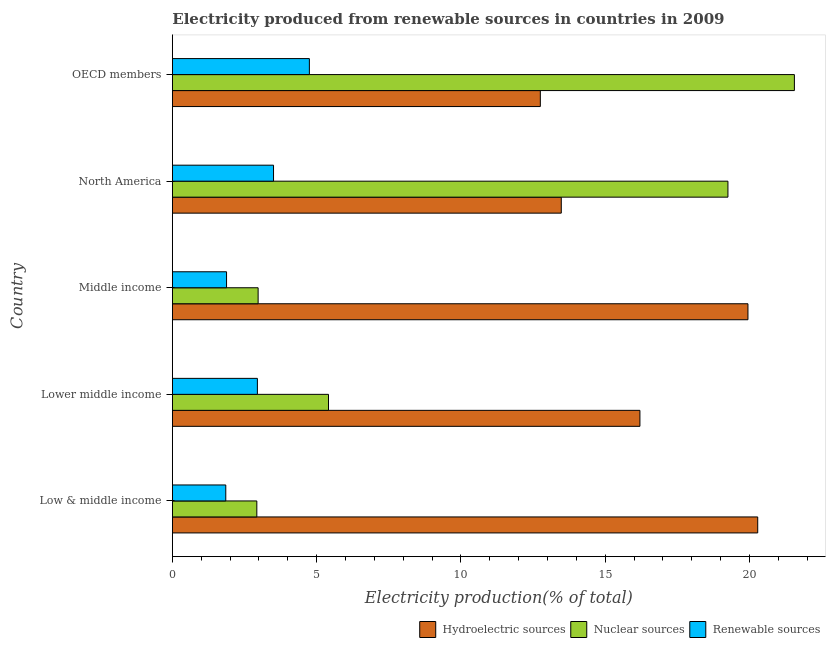How many different coloured bars are there?
Offer a very short reply. 3. Are the number of bars on each tick of the Y-axis equal?
Your response must be concise. Yes. What is the label of the 3rd group of bars from the top?
Ensure brevity in your answer.  Middle income. What is the percentage of electricity produced by hydroelectric sources in Low & middle income?
Give a very brief answer. 20.29. Across all countries, what is the maximum percentage of electricity produced by nuclear sources?
Your answer should be very brief. 21.56. Across all countries, what is the minimum percentage of electricity produced by renewable sources?
Give a very brief answer. 1.85. What is the total percentage of electricity produced by nuclear sources in the graph?
Offer a terse response. 52.12. What is the difference between the percentage of electricity produced by hydroelectric sources in Lower middle income and that in OECD members?
Give a very brief answer. 3.45. What is the difference between the percentage of electricity produced by hydroelectric sources in Low & middle income and the percentage of electricity produced by renewable sources in OECD members?
Offer a terse response. 15.54. What is the average percentage of electricity produced by hydroelectric sources per country?
Give a very brief answer. 16.54. What is the difference between the percentage of electricity produced by nuclear sources and percentage of electricity produced by renewable sources in Lower middle income?
Your answer should be compact. 2.46. What is the ratio of the percentage of electricity produced by hydroelectric sources in Middle income to that in North America?
Offer a very short reply. 1.48. What is the difference between the highest and the second highest percentage of electricity produced by hydroelectric sources?
Offer a very short reply. 0.34. What is the difference between the highest and the lowest percentage of electricity produced by hydroelectric sources?
Offer a very short reply. 7.53. Is the sum of the percentage of electricity produced by nuclear sources in Lower middle income and OECD members greater than the maximum percentage of electricity produced by hydroelectric sources across all countries?
Give a very brief answer. Yes. What does the 3rd bar from the top in OECD members represents?
Offer a terse response. Hydroelectric sources. What does the 3rd bar from the bottom in Lower middle income represents?
Keep it short and to the point. Renewable sources. How many countries are there in the graph?
Ensure brevity in your answer.  5. What is the difference between two consecutive major ticks on the X-axis?
Give a very brief answer. 5. Does the graph contain grids?
Your response must be concise. No. How many legend labels are there?
Ensure brevity in your answer.  3. How are the legend labels stacked?
Your answer should be compact. Horizontal. What is the title of the graph?
Ensure brevity in your answer.  Electricity produced from renewable sources in countries in 2009. Does "Agriculture" appear as one of the legend labels in the graph?
Provide a succinct answer. No. What is the label or title of the X-axis?
Keep it short and to the point. Electricity production(% of total). What is the Electricity production(% of total) in Hydroelectric sources in Low & middle income?
Offer a terse response. 20.29. What is the Electricity production(% of total) of Nuclear sources in Low & middle income?
Your answer should be very brief. 2.93. What is the Electricity production(% of total) in Renewable sources in Low & middle income?
Provide a succinct answer. 1.85. What is the Electricity production(% of total) of Hydroelectric sources in Lower middle income?
Ensure brevity in your answer.  16.2. What is the Electricity production(% of total) of Nuclear sources in Lower middle income?
Provide a succinct answer. 5.41. What is the Electricity production(% of total) in Renewable sources in Lower middle income?
Your response must be concise. 2.95. What is the Electricity production(% of total) in Hydroelectric sources in Middle income?
Offer a very short reply. 19.95. What is the Electricity production(% of total) in Nuclear sources in Middle income?
Your response must be concise. 2.97. What is the Electricity production(% of total) of Renewable sources in Middle income?
Your answer should be compact. 1.88. What is the Electricity production(% of total) of Hydroelectric sources in North America?
Your response must be concise. 13.48. What is the Electricity production(% of total) of Nuclear sources in North America?
Your answer should be very brief. 19.26. What is the Electricity production(% of total) of Renewable sources in North America?
Make the answer very short. 3.51. What is the Electricity production(% of total) of Hydroelectric sources in OECD members?
Your response must be concise. 12.75. What is the Electricity production(% of total) in Nuclear sources in OECD members?
Your response must be concise. 21.56. What is the Electricity production(% of total) in Renewable sources in OECD members?
Keep it short and to the point. 4.75. Across all countries, what is the maximum Electricity production(% of total) of Hydroelectric sources?
Provide a succinct answer. 20.29. Across all countries, what is the maximum Electricity production(% of total) in Nuclear sources?
Make the answer very short. 21.56. Across all countries, what is the maximum Electricity production(% of total) in Renewable sources?
Your answer should be compact. 4.75. Across all countries, what is the minimum Electricity production(% of total) in Hydroelectric sources?
Keep it short and to the point. 12.75. Across all countries, what is the minimum Electricity production(% of total) in Nuclear sources?
Make the answer very short. 2.93. Across all countries, what is the minimum Electricity production(% of total) in Renewable sources?
Your answer should be very brief. 1.85. What is the total Electricity production(% of total) in Hydroelectric sources in the graph?
Your answer should be compact. 82.67. What is the total Electricity production(% of total) in Nuclear sources in the graph?
Provide a short and direct response. 52.12. What is the total Electricity production(% of total) in Renewable sources in the graph?
Offer a terse response. 14.93. What is the difference between the Electricity production(% of total) in Hydroelectric sources in Low & middle income and that in Lower middle income?
Offer a terse response. 4.08. What is the difference between the Electricity production(% of total) in Nuclear sources in Low & middle income and that in Lower middle income?
Ensure brevity in your answer.  -2.48. What is the difference between the Electricity production(% of total) of Renewable sources in Low & middle income and that in Lower middle income?
Your answer should be compact. -1.1. What is the difference between the Electricity production(% of total) in Hydroelectric sources in Low & middle income and that in Middle income?
Your answer should be very brief. 0.34. What is the difference between the Electricity production(% of total) of Nuclear sources in Low & middle income and that in Middle income?
Your answer should be very brief. -0.04. What is the difference between the Electricity production(% of total) of Renewable sources in Low & middle income and that in Middle income?
Offer a very short reply. -0.03. What is the difference between the Electricity production(% of total) of Hydroelectric sources in Low & middle income and that in North America?
Provide a succinct answer. 6.81. What is the difference between the Electricity production(% of total) of Nuclear sources in Low & middle income and that in North America?
Your answer should be very brief. -16.33. What is the difference between the Electricity production(% of total) of Renewable sources in Low & middle income and that in North America?
Provide a succinct answer. -1.65. What is the difference between the Electricity production(% of total) of Hydroelectric sources in Low & middle income and that in OECD members?
Offer a very short reply. 7.53. What is the difference between the Electricity production(% of total) in Nuclear sources in Low & middle income and that in OECD members?
Your answer should be compact. -18.63. What is the difference between the Electricity production(% of total) of Renewable sources in Low & middle income and that in OECD members?
Make the answer very short. -2.9. What is the difference between the Electricity production(% of total) of Hydroelectric sources in Lower middle income and that in Middle income?
Offer a very short reply. -3.74. What is the difference between the Electricity production(% of total) of Nuclear sources in Lower middle income and that in Middle income?
Provide a succinct answer. 2.44. What is the difference between the Electricity production(% of total) of Renewable sources in Lower middle income and that in Middle income?
Provide a succinct answer. 1.07. What is the difference between the Electricity production(% of total) of Hydroelectric sources in Lower middle income and that in North America?
Make the answer very short. 2.73. What is the difference between the Electricity production(% of total) of Nuclear sources in Lower middle income and that in North America?
Offer a very short reply. -13.84. What is the difference between the Electricity production(% of total) of Renewable sources in Lower middle income and that in North America?
Offer a terse response. -0.56. What is the difference between the Electricity production(% of total) of Hydroelectric sources in Lower middle income and that in OECD members?
Keep it short and to the point. 3.45. What is the difference between the Electricity production(% of total) in Nuclear sources in Lower middle income and that in OECD members?
Offer a very short reply. -16.15. What is the difference between the Electricity production(% of total) of Renewable sources in Lower middle income and that in OECD members?
Keep it short and to the point. -1.8. What is the difference between the Electricity production(% of total) of Hydroelectric sources in Middle income and that in North America?
Give a very brief answer. 6.47. What is the difference between the Electricity production(% of total) of Nuclear sources in Middle income and that in North America?
Offer a terse response. -16.28. What is the difference between the Electricity production(% of total) of Renewable sources in Middle income and that in North America?
Your answer should be very brief. -1.63. What is the difference between the Electricity production(% of total) in Hydroelectric sources in Middle income and that in OECD members?
Your response must be concise. 7.2. What is the difference between the Electricity production(% of total) of Nuclear sources in Middle income and that in OECD members?
Your answer should be very brief. -18.59. What is the difference between the Electricity production(% of total) in Renewable sources in Middle income and that in OECD members?
Give a very brief answer. -2.87. What is the difference between the Electricity production(% of total) of Hydroelectric sources in North America and that in OECD members?
Make the answer very short. 0.73. What is the difference between the Electricity production(% of total) in Nuclear sources in North America and that in OECD members?
Make the answer very short. -2.3. What is the difference between the Electricity production(% of total) in Renewable sources in North America and that in OECD members?
Keep it short and to the point. -1.24. What is the difference between the Electricity production(% of total) of Hydroelectric sources in Low & middle income and the Electricity production(% of total) of Nuclear sources in Lower middle income?
Make the answer very short. 14.88. What is the difference between the Electricity production(% of total) in Hydroelectric sources in Low & middle income and the Electricity production(% of total) in Renewable sources in Lower middle income?
Keep it short and to the point. 17.34. What is the difference between the Electricity production(% of total) of Nuclear sources in Low & middle income and the Electricity production(% of total) of Renewable sources in Lower middle income?
Your answer should be very brief. -0.02. What is the difference between the Electricity production(% of total) of Hydroelectric sources in Low & middle income and the Electricity production(% of total) of Nuclear sources in Middle income?
Provide a succinct answer. 17.32. What is the difference between the Electricity production(% of total) in Hydroelectric sources in Low & middle income and the Electricity production(% of total) in Renewable sources in Middle income?
Offer a terse response. 18.41. What is the difference between the Electricity production(% of total) in Nuclear sources in Low & middle income and the Electricity production(% of total) in Renewable sources in Middle income?
Ensure brevity in your answer.  1.05. What is the difference between the Electricity production(% of total) of Hydroelectric sources in Low & middle income and the Electricity production(% of total) of Nuclear sources in North America?
Make the answer very short. 1.03. What is the difference between the Electricity production(% of total) in Hydroelectric sources in Low & middle income and the Electricity production(% of total) in Renewable sources in North America?
Offer a very short reply. 16.78. What is the difference between the Electricity production(% of total) of Nuclear sources in Low & middle income and the Electricity production(% of total) of Renewable sources in North America?
Your answer should be very brief. -0.58. What is the difference between the Electricity production(% of total) of Hydroelectric sources in Low & middle income and the Electricity production(% of total) of Nuclear sources in OECD members?
Make the answer very short. -1.27. What is the difference between the Electricity production(% of total) of Hydroelectric sources in Low & middle income and the Electricity production(% of total) of Renewable sources in OECD members?
Offer a terse response. 15.54. What is the difference between the Electricity production(% of total) of Nuclear sources in Low & middle income and the Electricity production(% of total) of Renewable sources in OECD members?
Your response must be concise. -1.82. What is the difference between the Electricity production(% of total) of Hydroelectric sources in Lower middle income and the Electricity production(% of total) of Nuclear sources in Middle income?
Give a very brief answer. 13.23. What is the difference between the Electricity production(% of total) in Hydroelectric sources in Lower middle income and the Electricity production(% of total) in Renewable sources in Middle income?
Offer a terse response. 14.33. What is the difference between the Electricity production(% of total) in Nuclear sources in Lower middle income and the Electricity production(% of total) in Renewable sources in Middle income?
Provide a succinct answer. 3.53. What is the difference between the Electricity production(% of total) in Hydroelectric sources in Lower middle income and the Electricity production(% of total) in Nuclear sources in North America?
Offer a terse response. -3.05. What is the difference between the Electricity production(% of total) of Hydroelectric sources in Lower middle income and the Electricity production(% of total) of Renewable sources in North America?
Make the answer very short. 12.7. What is the difference between the Electricity production(% of total) of Nuclear sources in Lower middle income and the Electricity production(% of total) of Renewable sources in North America?
Your answer should be very brief. 1.91. What is the difference between the Electricity production(% of total) in Hydroelectric sources in Lower middle income and the Electricity production(% of total) in Nuclear sources in OECD members?
Offer a terse response. -5.35. What is the difference between the Electricity production(% of total) in Hydroelectric sources in Lower middle income and the Electricity production(% of total) in Renewable sources in OECD members?
Keep it short and to the point. 11.46. What is the difference between the Electricity production(% of total) in Nuclear sources in Lower middle income and the Electricity production(% of total) in Renewable sources in OECD members?
Keep it short and to the point. 0.66. What is the difference between the Electricity production(% of total) of Hydroelectric sources in Middle income and the Electricity production(% of total) of Nuclear sources in North America?
Give a very brief answer. 0.69. What is the difference between the Electricity production(% of total) in Hydroelectric sources in Middle income and the Electricity production(% of total) in Renewable sources in North America?
Offer a terse response. 16.44. What is the difference between the Electricity production(% of total) in Nuclear sources in Middle income and the Electricity production(% of total) in Renewable sources in North America?
Your answer should be compact. -0.53. What is the difference between the Electricity production(% of total) of Hydroelectric sources in Middle income and the Electricity production(% of total) of Nuclear sources in OECD members?
Provide a succinct answer. -1.61. What is the difference between the Electricity production(% of total) in Hydroelectric sources in Middle income and the Electricity production(% of total) in Renewable sources in OECD members?
Offer a very short reply. 15.2. What is the difference between the Electricity production(% of total) in Nuclear sources in Middle income and the Electricity production(% of total) in Renewable sources in OECD members?
Your response must be concise. -1.78. What is the difference between the Electricity production(% of total) in Hydroelectric sources in North America and the Electricity production(% of total) in Nuclear sources in OECD members?
Provide a short and direct response. -8.08. What is the difference between the Electricity production(% of total) of Hydroelectric sources in North America and the Electricity production(% of total) of Renewable sources in OECD members?
Your response must be concise. 8.73. What is the difference between the Electricity production(% of total) of Nuclear sources in North America and the Electricity production(% of total) of Renewable sources in OECD members?
Offer a very short reply. 14.51. What is the average Electricity production(% of total) in Hydroelectric sources per country?
Provide a succinct answer. 16.53. What is the average Electricity production(% of total) of Nuclear sources per country?
Your answer should be compact. 10.42. What is the average Electricity production(% of total) of Renewable sources per country?
Provide a succinct answer. 2.99. What is the difference between the Electricity production(% of total) in Hydroelectric sources and Electricity production(% of total) in Nuclear sources in Low & middle income?
Provide a short and direct response. 17.36. What is the difference between the Electricity production(% of total) of Hydroelectric sources and Electricity production(% of total) of Renewable sources in Low & middle income?
Ensure brevity in your answer.  18.44. What is the difference between the Electricity production(% of total) in Nuclear sources and Electricity production(% of total) in Renewable sources in Low & middle income?
Ensure brevity in your answer.  1.08. What is the difference between the Electricity production(% of total) of Hydroelectric sources and Electricity production(% of total) of Nuclear sources in Lower middle income?
Provide a short and direct response. 10.79. What is the difference between the Electricity production(% of total) of Hydroelectric sources and Electricity production(% of total) of Renewable sources in Lower middle income?
Your answer should be very brief. 13.26. What is the difference between the Electricity production(% of total) in Nuclear sources and Electricity production(% of total) in Renewable sources in Lower middle income?
Make the answer very short. 2.46. What is the difference between the Electricity production(% of total) in Hydroelectric sources and Electricity production(% of total) in Nuclear sources in Middle income?
Provide a succinct answer. 16.98. What is the difference between the Electricity production(% of total) of Hydroelectric sources and Electricity production(% of total) of Renewable sources in Middle income?
Ensure brevity in your answer.  18.07. What is the difference between the Electricity production(% of total) of Nuclear sources and Electricity production(% of total) of Renewable sources in Middle income?
Provide a short and direct response. 1.09. What is the difference between the Electricity production(% of total) of Hydroelectric sources and Electricity production(% of total) of Nuclear sources in North America?
Keep it short and to the point. -5.78. What is the difference between the Electricity production(% of total) in Hydroelectric sources and Electricity production(% of total) in Renewable sources in North America?
Provide a succinct answer. 9.97. What is the difference between the Electricity production(% of total) in Nuclear sources and Electricity production(% of total) in Renewable sources in North America?
Keep it short and to the point. 15.75. What is the difference between the Electricity production(% of total) in Hydroelectric sources and Electricity production(% of total) in Nuclear sources in OECD members?
Your response must be concise. -8.81. What is the difference between the Electricity production(% of total) of Hydroelectric sources and Electricity production(% of total) of Renewable sources in OECD members?
Your answer should be compact. 8. What is the difference between the Electricity production(% of total) in Nuclear sources and Electricity production(% of total) in Renewable sources in OECD members?
Offer a very short reply. 16.81. What is the ratio of the Electricity production(% of total) in Hydroelectric sources in Low & middle income to that in Lower middle income?
Provide a succinct answer. 1.25. What is the ratio of the Electricity production(% of total) in Nuclear sources in Low & middle income to that in Lower middle income?
Ensure brevity in your answer.  0.54. What is the ratio of the Electricity production(% of total) in Renewable sources in Low & middle income to that in Lower middle income?
Offer a terse response. 0.63. What is the ratio of the Electricity production(% of total) of Hydroelectric sources in Low & middle income to that in Middle income?
Offer a very short reply. 1.02. What is the ratio of the Electricity production(% of total) of Nuclear sources in Low & middle income to that in Middle income?
Provide a succinct answer. 0.98. What is the ratio of the Electricity production(% of total) of Renewable sources in Low & middle income to that in Middle income?
Your answer should be compact. 0.99. What is the ratio of the Electricity production(% of total) of Hydroelectric sources in Low & middle income to that in North America?
Your answer should be compact. 1.51. What is the ratio of the Electricity production(% of total) in Nuclear sources in Low & middle income to that in North America?
Your answer should be compact. 0.15. What is the ratio of the Electricity production(% of total) in Renewable sources in Low & middle income to that in North America?
Keep it short and to the point. 0.53. What is the ratio of the Electricity production(% of total) in Hydroelectric sources in Low & middle income to that in OECD members?
Give a very brief answer. 1.59. What is the ratio of the Electricity production(% of total) of Nuclear sources in Low & middle income to that in OECD members?
Ensure brevity in your answer.  0.14. What is the ratio of the Electricity production(% of total) in Renewable sources in Low & middle income to that in OECD members?
Offer a very short reply. 0.39. What is the ratio of the Electricity production(% of total) of Hydroelectric sources in Lower middle income to that in Middle income?
Your answer should be compact. 0.81. What is the ratio of the Electricity production(% of total) of Nuclear sources in Lower middle income to that in Middle income?
Ensure brevity in your answer.  1.82. What is the ratio of the Electricity production(% of total) of Renewable sources in Lower middle income to that in Middle income?
Ensure brevity in your answer.  1.57. What is the ratio of the Electricity production(% of total) of Hydroelectric sources in Lower middle income to that in North America?
Ensure brevity in your answer.  1.2. What is the ratio of the Electricity production(% of total) in Nuclear sources in Lower middle income to that in North America?
Provide a succinct answer. 0.28. What is the ratio of the Electricity production(% of total) of Renewable sources in Lower middle income to that in North America?
Provide a succinct answer. 0.84. What is the ratio of the Electricity production(% of total) of Hydroelectric sources in Lower middle income to that in OECD members?
Give a very brief answer. 1.27. What is the ratio of the Electricity production(% of total) of Nuclear sources in Lower middle income to that in OECD members?
Ensure brevity in your answer.  0.25. What is the ratio of the Electricity production(% of total) of Renewable sources in Lower middle income to that in OECD members?
Make the answer very short. 0.62. What is the ratio of the Electricity production(% of total) in Hydroelectric sources in Middle income to that in North America?
Keep it short and to the point. 1.48. What is the ratio of the Electricity production(% of total) of Nuclear sources in Middle income to that in North America?
Provide a short and direct response. 0.15. What is the ratio of the Electricity production(% of total) of Renewable sources in Middle income to that in North America?
Your answer should be compact. 0.54. What is the ratio of the Electricity production(% of total) in Hydroelectric sources in Middle income to that in OECD members?
Offer a terse response. 1.56. What is the ratio of the Electricity production(% of total) in Nuclear sources in Middle income to that in OECD members?
Make the answer very short. 0.14. What is the ratio of the Electricity production(% of total) of Renewable sources in Middle income to that in OECD members?
Offer a very short reply. 0.4. What is the ratio of the Electricity production(% of total) of Hydroelectric sources in North America to that in OECD members?
Make the answer very short. 1.06. What is the ratio of the Electricity production(% of total) of Nuclear sources in North America to that in OECD members?
Your answer should be very brief. 0.89. What is the ratio of the Electricity production(% of total) of Renewable sources in North America to that in OECD members?
Give a very brief answer. 0.74. What is the difference between the highest and the second highest Electricity production(% of total) of Hydroelectric sources?
Ensure brevity in your answer.  0.34. What is the difference between the highest and the second highest Electricity production(% of total) of Nuclear sources?
Offer a terse response. 2.3. What is the difference between the highest and the second highest Electricity production(% of total) of Renewable sources?
Your answer should be very brief. 1.24. What is the difference between the highest and the lowest Electricity production(% of total) in Hydroelectric sources?
Keep it short and to the point. 7.53. What is the difference between the highest and the lowest Electricity production(% of total) of Nuclear sources?
Offer a terse response. 18.63. What is the difference between the highest and the lowest Electricity production(% of total) in Renewable sources?
Offer a very short reply. 2.9. 